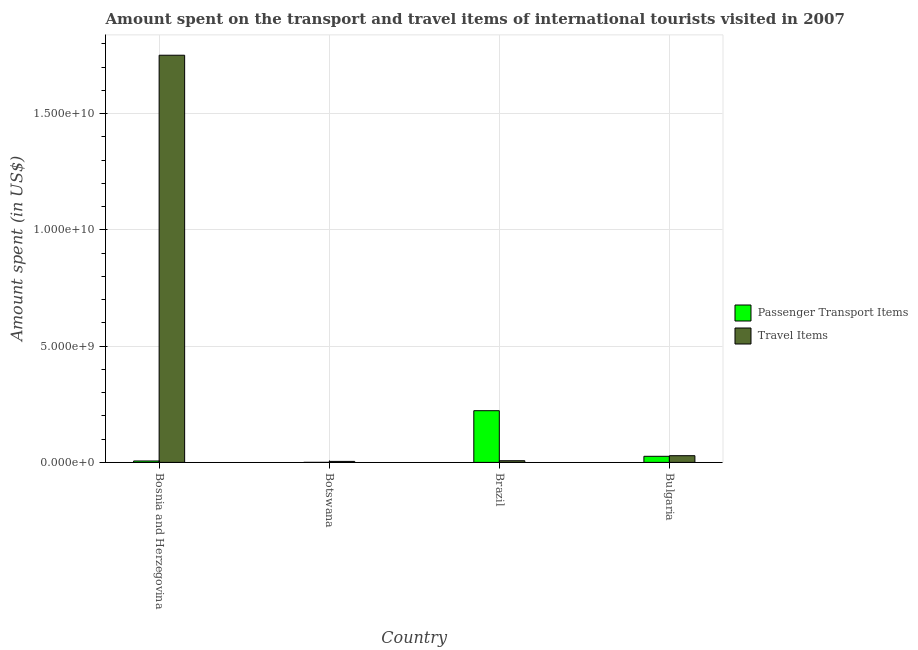Are the number of bars on each tick of the X-axis equal?
Provide a short and direct response. Yes. What is the label of the 1st group of bars from the left?
Ensure brevity in your answer.  Bosnia and Herzegovina. In how many cases, is the number of bars for a given country not equal to the number of legend labels?
Provide a succinct answer. 0. What is the amount spent on passenger transport items in Botswana?
Your answer should be very brief. 1.00e+06. Across all countries, what is the maximum amount spent in travel items?
Your answer should be compact. 1.75e+1. In which country was the amount spent in travel items maximum?
Your response must be concise. Bosnia and Herzegovina. In which country was the amount spent in travel items minimum?
Your answer should be compact. Botswana. What is the total amount spent in travel items in the graph?
Provide a succinct answer. 1.79e+1. What is the difference between the amount spent on passenger transport items in Bosnia and Herzegovina and that in Botswana?
Offer a very short reply. 6.00e+07. What is the difference between the amount spent on passenger transport items in Brazil and the amount spent in travel items in Botswana?
Ensure brevity in your answer.  2.18e+09. What is the average amount spent on passenger transport items per country?
Offer a very short reply. 6.37e+08. What is the difference between the amount spent on passenger transport items and amount spent in travel items in Bosnia and Herzegovina?
Provide a succinct answer. -1.74e+1. In how many countries, is the amount spent in travel items greater than 11000000000 US$?
Offer a very short reply. 1. What is the ratio of the amount spent in travel items in Bosnia and Herzegovina to that in Brazil?
Offer a very short reply. 243.14. Is the amount spent in travel items in Botswana less than that in Brazil?
Your answer should be very brief. Yes. Is the difference between the amount spent on passenger transport items in Bosnia and Herzegovina and Brazil greater than the difference between the amount spent in travel items in Bosnia and Herzegovina and Brazil?
Provide a succinct answer. No. What is the difference between the highest and the second highest amount spent in travel items?
Keep it short and to the point. 1.72e+1. What is the difference between the highest and the lowest amount spent in travel items?
Ensure brevity in your answer.  1.75e+1. In how many countries, is the amount spent on passenger transport items greater than the average amount spent on passenger transport items taken over all countries?
Give a very brief answer. 1. What does the 1st bar from the left in Brazil represents?
Offer a very short reply. Passenger Transport Items. What does the 2nd bar from the right in Brazil represents?
Keep it short and to the point. Passenger Transport Items. How many bars are there?
Offer a terse response. 8. Are all the bars in the graph horizontal?
Give a very brief answer. No. Are the values on the major ticks of Y-axis written in scientific E-notation?
Offer a terse response. Yes. Does the graph contain any zero values?
Your answer should be compact. No. Does the graph contain grids?
Provide a succinct answer. Yes. How many legend labels are there?
Your answer should be compact. 2. What is the title of the graph?
Your response must be concise. Amount spent on the transport and travel items of international tourists visited in 2007. Does "Highest 20% of population" appear as one of the legend labels in the graph?
Offer a very short reply. No. What is the label or title of the Y-axis?
Your response must be concise. Amount spent (in US$). What is the Amount spent (in US$) of Passenger Transport Items in Bosnia and Herzegovina?
Your answer should be compact. 6.10e+07. What is the Amount spent (in US$) of Travel Items in Bosnia and Herzegovina?
Offer a very short reply. 1.75e+1. What is the Amount spent (in US$) in Passenger Transport Items in Botswana?
Offer a very short reply. 1.00e+06. What is the Amount spent (in US$) in Travel Items in Botswana?
Ensure brevity in your answer.  4.30e+07. What is the Amount spent (in US$) of Passenger Transport Items in Brazil?
Offer a very short reply. 2.22e+09. What is the Amount spent (in US$) of Travel Items in Brazil?
Provide a short and direct response. 7.20e+07. What is the Amount spent (in US$) of Passenger Transport Items in Bulgaria?
Offer a very short reply. 2.62e+08. What is the Amount spent (in US$) in Travel Items in Bulgaria?
Keep it short and to the point. 2.88e+08. Across all countries, what is the maximum Amount spent (in US$) in Passenger Transport Items?
Your answer should be compact. 2.22e+09. Across all countries, what is the maximum Amount spent (in US$) of Travel Items?
Your response must be concise. 1.75e+1. Across all countries, what is the minimum Amount spent (in US$) in Travel Items?
Offer a terse response. 4.30e+07. What is the total Amount spent (in US$) of Passenger Transport Items in the graph?
Offer a terse response. 2.55e+09. What is the total Amount spent (in US$) of Travel Items in the graph?
Your response must be concise. 1.79e+1. What is the difference between the Amount spent (in US$) in Passenger Transport Items in Bosnia and Herzegovina and that in Botswana?
Your answer should be very brief. 6.00e+07. What is the difference between the Amount spent (in US$) of Travel Items in Bosnia and Herzegovina and that in Botswana?
Your answer should be compact. 1.75e+1. What is the difference between the Amount spent (in US$) of Passenger Transport Items in Bosnia and Herzegovina and that in Brazil?
Ensure brevity in your answer.  -2.16e+09. What is the difference between the Amount spent (in US$) in Travel Items in Bosnia and Herzegovina and that in Brazil?
Offer a terse response. 1.74e+1. What is the difference between the Amount spent (in US$) of Passenger Transport Items in Bosnia and Herzegovina and that in Bulgaria?
Your answer should be very brief. -2.01e+08. What is the difference between the Amount spent (in US$) in Travel Items in Bosnia and Herzegovina and that in Bulgaria?
Make the answer very short. 1.72e+1. What is the difference between the Amount spent (in US$) of Passenger Transport Items in Botswana and that in Brazil?
Provide a short and direct response. -2.22e+09. What is the difference between the Amount spent (in US$) of Travel Items in Botswana and that in Brazil?
Provide a short and direct response. -2.90e+07. What is the difference between the Amount spent (in US$) of Passenger Transport Items in Botswana and that in Bulgaria?
Offer a very short reply. -2.61e+08. What is the difference between the Amount spent (in US$) in Travel Items in Botswana and that in Bulgaria?
Your answer should be very brief. -2.45e+08. What is the difference between the Amount spent (in US$) of Passenger Transport Items in Brazil and that in Bulgaria?
Offer a terse response. 1.96e+09. What is the difference between the Amount spent (in US$) of Travel Items in Brazil and that in Bulgaria?
Your response must be concise. -2.16e+08. What is the difference between the Amount spent (in US$) of Passenger Transport Items in Bosnia and Herzegovina and the Amount spent (in US$) of Travel Items in Botswana?
Provide a succinct answer. 1.80e+07. What is the difference between the Amount spent (in US$) in Passenger Transport Items in Bosnia and Herzegovina and the Amount spent (in US$) in Travel Items in Brazil?
Your response must be concise. -1.10e+07. What is the difference between the Amount spent (in US$) of Passenger Transport Items in Bosnia and Herzegovina and the Amount spent (in US$) of Travel Items in Bulgaria?
Your answer should be compact. -2.27e+08. What is the difference between the Amount spent (in US$) in Passenger Transport Items in Botswana and the Amount spent (in US$) in Travel Items in Brazil?
Ensure brevity in your answer.  -7.10e+07. What is the difference between the Amount spent (in US$) in Passenger Transport Items in Botswana and the Amount spent (in US$) in Travel Items in Bulgaria?
Make the answer very short. -2.87e+08. What is the difference between the Amount spent (in US$) of Passenger Transport Items in Brazil and the Amount spent (in US$) of Travel Items in Bulgaria?
Provide a short and direct response. 1.94e+09. What is the average Amount spent (in US$) in Passenger Transport Items per country?
Offer a terse response. 6.37e+08. What is the average Amount spent (in US$) in Travel Items per country?
Ensure brevity in your answer.  4.48e+09. What is the difference between the Amount spent (in US$) of Passenger Transport Items and Amount spent (in US$) of Travel Items in Bosnia and Herzegovina?
Your answer should be very brief. -1.74e+1. What is the difference between the Amount spent (in US$) of Passenger Transport Items and Amount spent (in US$) of Travel Items in Botswana?
Offer a very short reply. -4.20e+07. What is the difference between the Amount spent (in US$) of Passenger Transport Items and Amount spent (in US$) of Travel Items in Brazil?
Your answer should be compact. 2.15e+09. What is the difference between the Amount spent (in US$) in Passenger Transport Items and Amount spent (in US$) in Travel Items in Bulgaria?
Offer a terse response. -2.60e+07. What is the ratio of the Amount spent (in US$) in Passenger Transport Items in Bosnia and Herzegovina to that in Botswana?
Give a very brief answer. 61. What is the ratio of the Amount spent (in US$) in Travel Items in Bosnia and Herzegovina to that in Botswana?
Ensure brevity in your answer.  407.12. What is the ratio of the Amount spent (in US$) of Passenger Transport Items in Bosnia and Herzegovina to that in Brazil?
Your answer should be very brief. 0.03. What is the ratio of the Amount spent (in US$) of Travel Items in Bosnia and Herzegovina to that in Brazil?
Make the answer very short. 243.14. What is the ratio of the Amount spent (in US$) in Passenger Transport Items in Bosnia and Herzegovina to that in Bulgaria?
Keep it short and to the point. 0.23. What is the ratio of the Amount spent (in US$) of Travel Items in Bosnia and Herzegovina to that in Bulgaria?
Offer a terse response. 60.78. What is the ratio of the Amount spent (in US$) in Travel Items in Botswana to that in Brazil?
Your answer should be compact. 0.6. What is the ratio of the Amount spent (in US$) of Passenger Transport Items in Botswana to that in Bulgaria?
Keep it short and to the point. 0. What is the ratio of the Amount spent (in US$) of Travel Items in Botswana to that in Bulgaria?
Make the answer very short. 0.15. What is the ratio of the Amount spent (in US$) in Passenger Transport Items in Brazil to that in Bulgaria?
Make the answer very short. 8.48. What is the difference between the highest and the second highest Amount spent (in US$) in Passenger Transport Items?
Ensure brevity in your answer.  1.96e+09. What is the difference between the highest and the second highest Amount spent (in US$) of Travel Items?
Offer a very short reply. 1.72e+1. What is the difference between the highest and the lowest Amount spent (in US$) of Passenger Transport Items?
Give a very brief answer. 2.22e+09. What is the difference between the highest and the lowest Amount spent (in US$) in Travel Items?
Keep it short and to the point. 1.75e+1. 